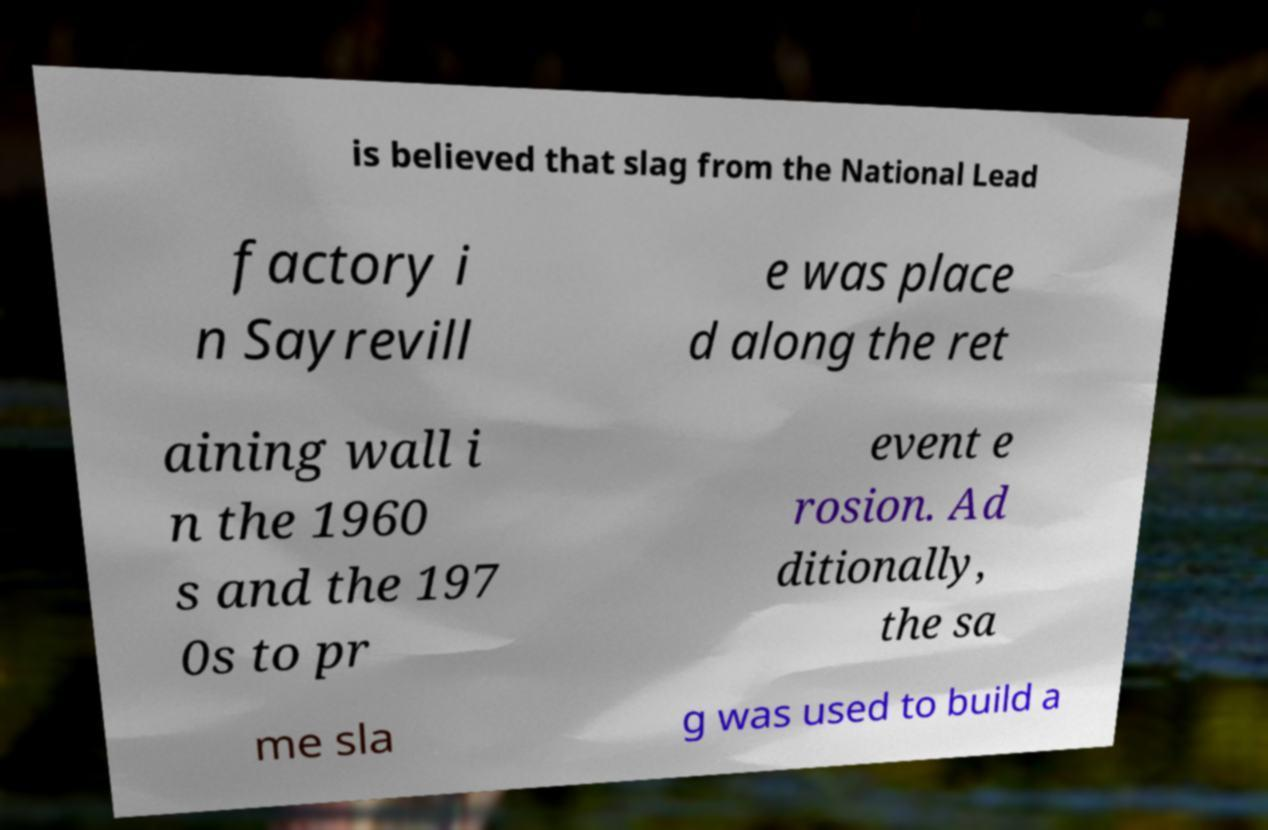Could you assist in decoding the text presented in this image and type it out clearly? is believed that slag from the National Lead factory i n Sayrevill e was place d along the ret aining wall i n the 1960 s and the 197 0s to pr event e rosion. Ad ditionally, the sa me sla g was used to build a 